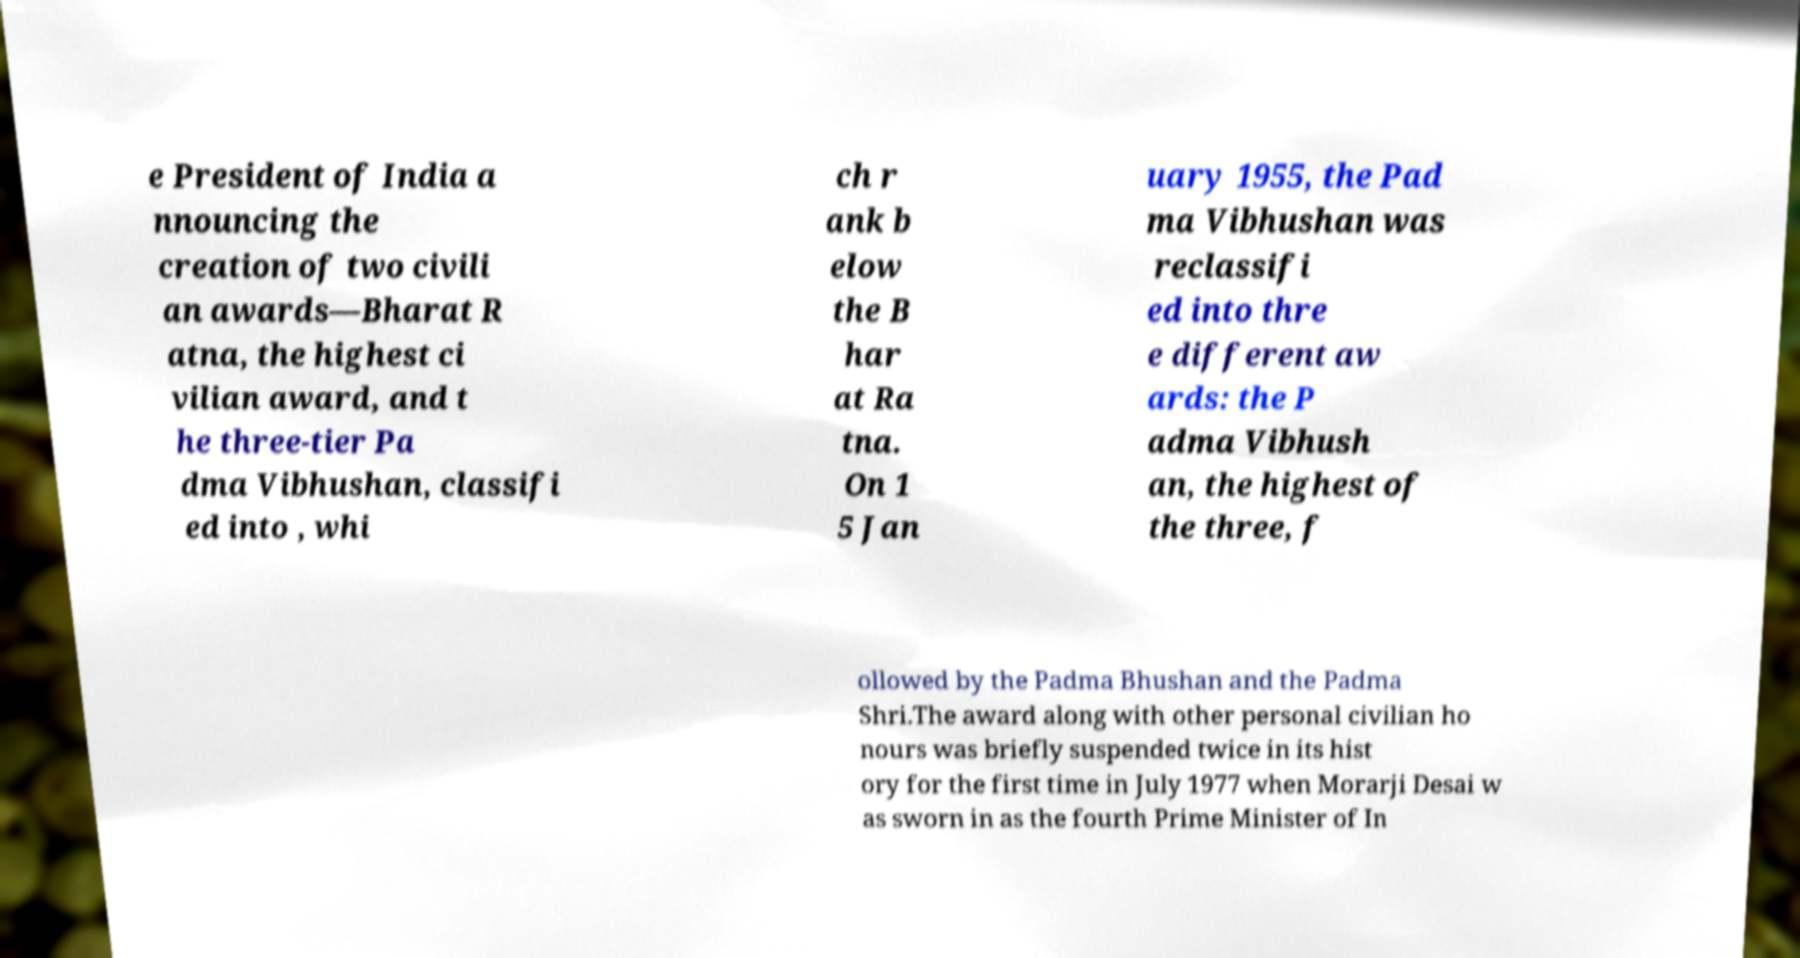There's text embedded in this image that I need extracted. Can you transcribe it verbatim? e President of India a nnouncing the creation of two civili an awards—Bharat R atna, the highest ci vilian award, and t he three-tier Pa dma Vibhushan, classifi ed into , whi ch r ank b elow the B har at Ra tna. On 1 5 Jan uary 1955, the Pad ma Vibhushan was reclassifi ed into thre e different aw ards: the P adma Vibhush an, the highest of the three, f ollowed by the Padma Bhushan and the Padma Shri.The award along with other personal civilian ho nours was briefly suspended twice in its hist ory for the first time in July 1977 when Morarji Desai w as sworn in as the fourth Prime Minister of In 